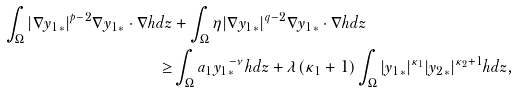<formula> <loc_0><loc_0><loc_500><loc_500>\int _ { \Omega } | \nabla { y _ { 1 } } _ { * } | ^ { p - 2 } \nabla { y _ { 1 } } _ { * } \cdot \nabla h d z & + \int _ { \Omega } \eta | \nabla { y _ { 1 } } _ { * } | ^ { q - 2 } \nabla { y _ { 1 } } _ { * } \cdot \nabla h d z \\ \geq & \int _ { \Omega } a _ { 1 } { y _ { 1 } } _ { * } ^ { - \nu } h d z + \lambda ( \kappa _ { 1 } + 1 ) \int _ { \Omega } | { y _ { 1 } } _ { * } | ^ { \kappa _ { 1 } } | { y _ { 2 } } _ { * } | ^ { \kappa _ { 2 } + 1 } h d z ,</formula> 